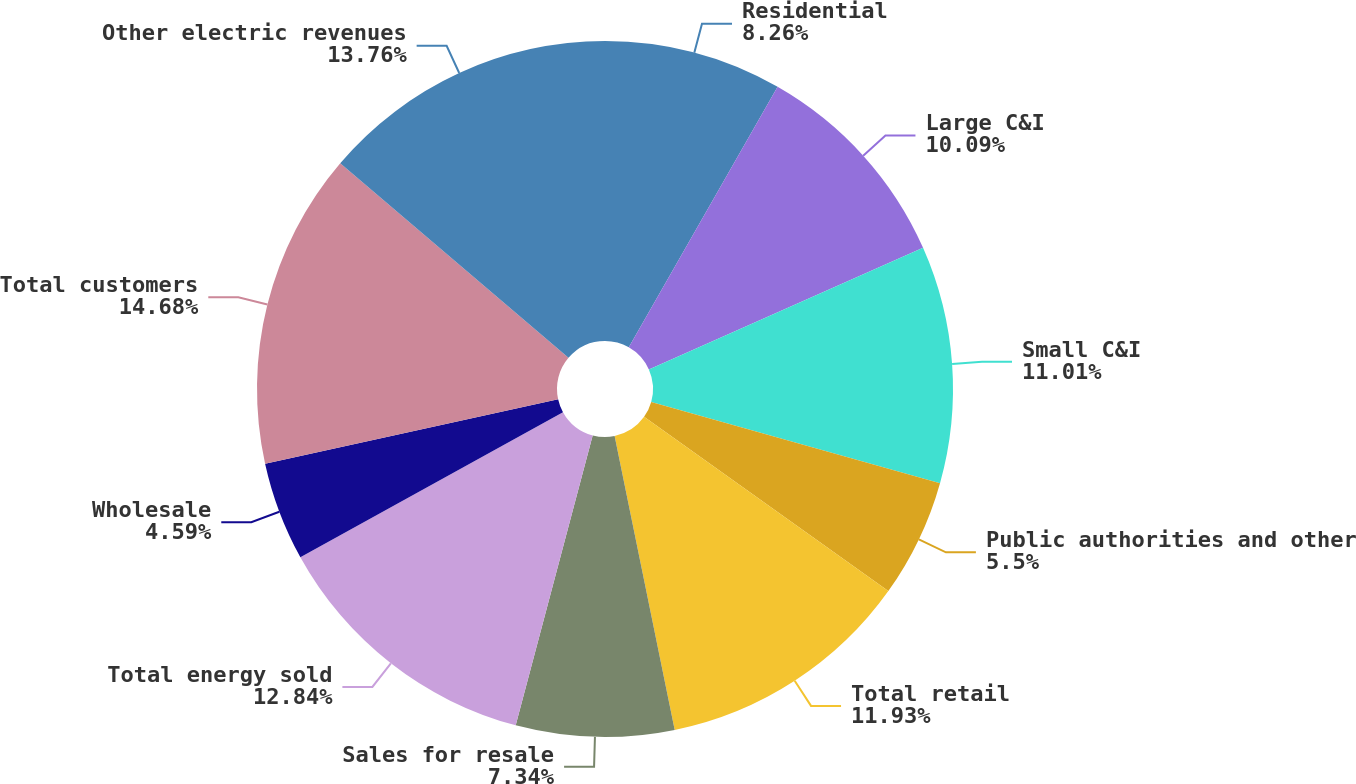Convert chart. <chart><loc_0><loc_0><loc_500><loc_500><pie_chart><fcel>Residential<fcel>Large C&I<fcel>Small C&I<fcel>Public authorities and other<fcel>Total retail<fcel>Sales for resale<fcel>Total energy sold<fcel>Wholesale<fcel>Total customers<fcel>Other electric revenues<nl><fcel>8.26%<fcel>10.09%<fcel>11.01%<fcel>5.5%<fcel>11.93%<fcel>7.34%<fcel>12.84%<fcel>4.59%<fcel>14.68%<fcel>13.76%<nl></chart> 